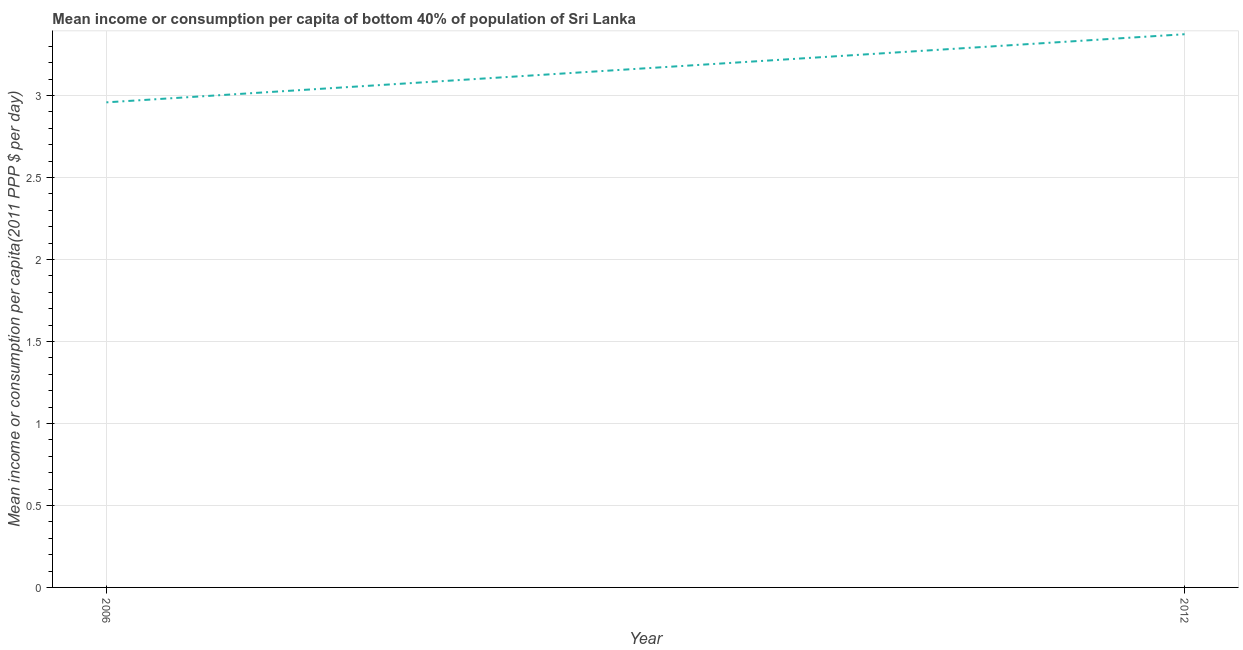What is the mean income or consumption in 2012?
Provide a short and direct response. 3.37. Across all years, what is the maximum mean income or consumption?
Keep it short and to the point. 3.37. Across all years, what is the minimum mean income or consumption?
Offer a very short reply. 2.96. What is the sum of the mean income or consumption?
Give a very brief answer. 6.33. What is the difference between the mean income or consumption in 2006 and 2012?
Ensure brevity in your answer.  -0.42. What is the average mean income or consumption per year?
Make the answer very short. 3.17. What is the median mean income or consumption?
Offer a terse response. 3.17. In how many years, is the mean income or consumption greater than 2.8 $?
Ensure brevity in your answer.  2. Do a majority of the years between 2006 and 2012 (inclusive) have mean income or consumption greater than 0.30000000000000004 $?
Offer a terse response. Yes. What is the ratio of the mean income or consumption in 2006 to that in 2012?
Offer a terse response. 0.88. How many lines are there?
Your answer should be compact. 1. Does the graph contain grids?
Your response must be concise. Yes. What is the title of the graph?
Provide a succinct answer. Mean income or consumption per capita of bottom 40% of population of Sri Lanka. What is the label or title of the X-axis?
Keep it short and to the point. Year. What is the label or title of the Y-axis?
Your answer should be compact. Mean income or consumption per capita(2011 PPP $ per day). What is the Mean income or consumption per capita(2011 PPP $ per day) in 2006?
Offer a very short reply. 2.96. What is the Mean income or consumption per capita(2011 PPP $ per day) of 2012?
Ensure brevity in your answer.  3.37. What is the difference between the Mean income or consumption per capita(2011 PPP $ per day) in 2006 and 2012?
Make the answer very short. -0.42. What is the ratio of the Mean income or consumption per capita(2011 PPP $ per day) in 2006 to that in 2012?
Keep it short and to the point. 0.88. 